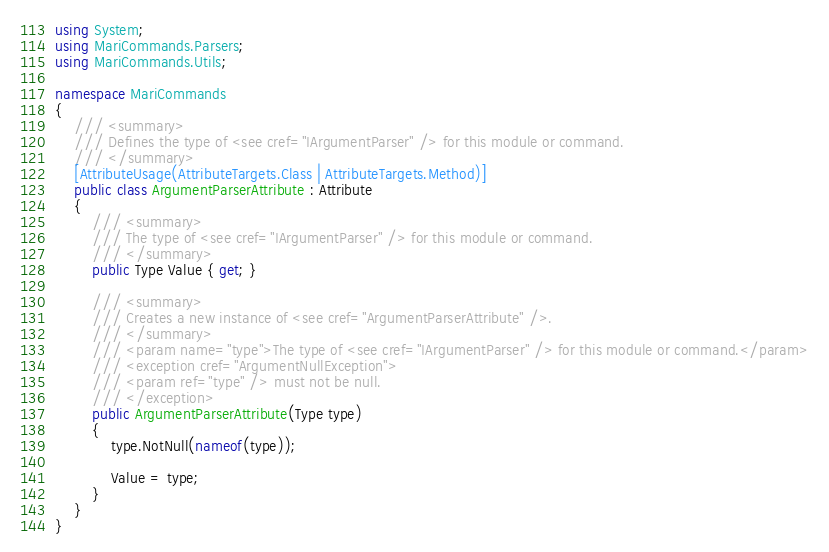<code> <loc_0><loc_0><loc_500><loc_500><_C#_>using System;
using MariCommands.Parsers;
using MariCommands.Utils;

namespace MariCommands
{
    /// <summary>
    /// Defines the type of <see cref="IArgumentParser" /> for this module or command.
    /// </summary>
    [AttributeUsage(AttributeTargets.Class | AttributeTargets.Method)]
    public class ArgumentParserAttribute : Attribute
    {
        /// <summary>
        /// The type of <see cref="IArgumentParser" /> for this module or command.
        /// </summary>
        public Type Value { get; }

        /// <summary>
        /// Creates a new instance of <see cref="ArgumentParserAttribute" />.
        /// </summary>
        /// <param name="type">The type of <see cref="IArgumentParser" /> for this module or command.</param>
        /// <exception cref="ArgumentNullException">
        /// <param ref="type" /> must not be null.
        /// </exception>
        public ArgumentParserAttribute(Type type)
        {
            type.NotNull(nameof(type));

            Value = type;
        }
    }
}</code> 